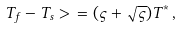Convert formula to latex. <formula><loc_0><loc_0><loc_500><loc_500>T _ { f } - T _ { s } > \ = ( \varsigma + \sqrt { \varsigma } ) T ^ { \ast } \, ,</formula> 